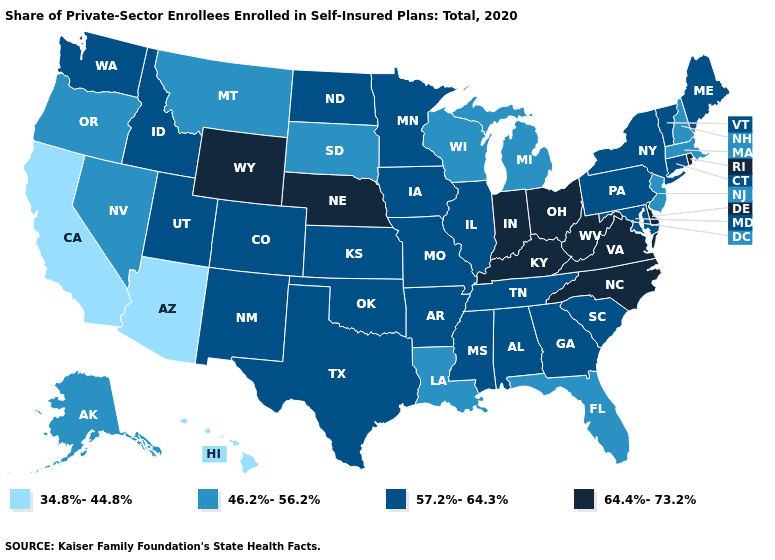Does Virginia have the highest value in the South?
Keep it brief. Yes. Does the first symbol in the legend represent the smallest category?
Answer briefly. Yes. How many symbols are there in the legend?
Be succinct. 4. Among the states that border Minnesota , which have the lowest value?
Answer briefly. South Dakota, Wisconsin. What is the value of Vermont?
Give a very brief answer. 57.2%-64.3%. Does Minnesota have a higher value than California?
Write a very short answer. Yes. Does California have the lowest value in the USA?
Answer briefly. Yes. Name the states that have a value in the range 34.8%-44.8%?
Give a very brief answer. Arizona, California, Hawaii. Name the states that have a value in the range 64.4%-73.2%?
Concise answer only. Delaware, Indiana, Kentucky, Nebraska, North Carolina, Ohio, Rhode Island, Virginia, West Virginia, Wyoming. Which states have the lowest value in the USA?
Write a very short answer. Arizona, California, Hawaii. Does Minnesota have a lower value than Virginia?
Write a very short answer. Yes. What is the value of North Carolina?
Short answer required. 64.4%-73.2%. Does Arizona have a lower value than Massachusetts?
Write a very short answer. Yes. What is the lowest value in the USA?
Answer briefly. 34.8%-44.8%. What is the highest value in states that border Wisconsin?
Write a very short answer. 57.2%-64.3%. 